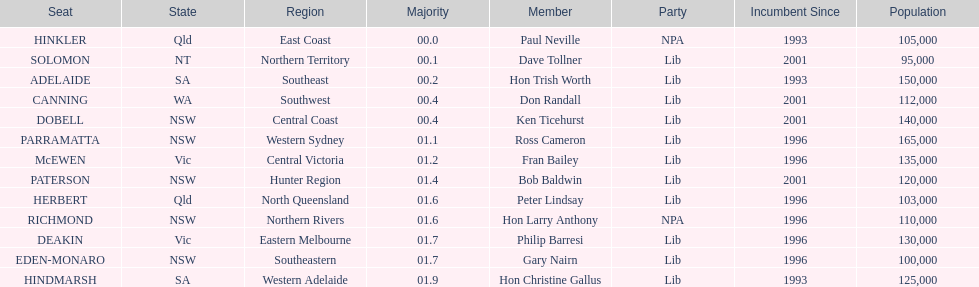What party had the most seats? Lib. 